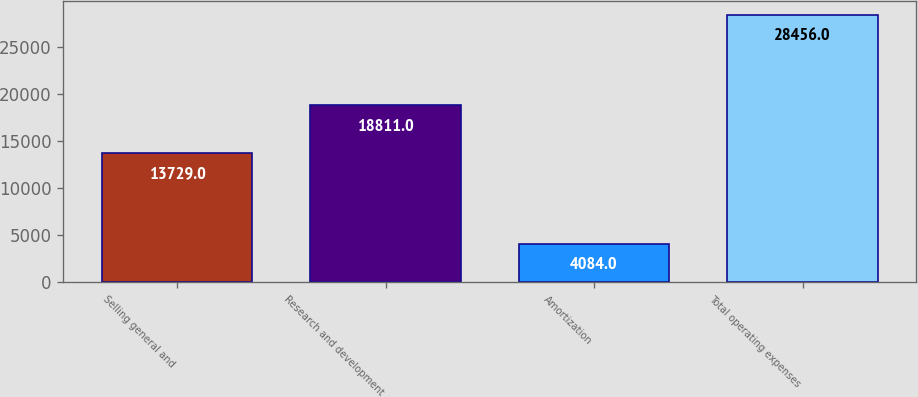<chart> <loc_0><loc_0><loc_500><loc_500><bar_chart><fcel>Selling general and<fcel>Research and development<fcel>Amortization<fcel>Total operating expenses<nl><fcel>13729<fcel>18811<fcel>4084<fcel>28456<nl></chart> 